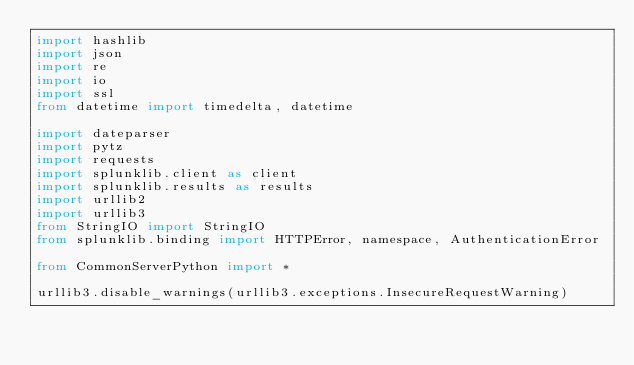<code> <loc_0><loc_0><loc_500><loc_500><_Python_>import hashlib
import json
import re
import io
import ssl
from datetime import timedelta, datetime

import dateparser
import pytz
import requests
import splunklib.client as client
import splunklib.results as results
import urllib2
import urllib3
from StringIO import StringIO
from splunklib.binding import HTTPError, namespace, AuthenticationError

from CommonServerPython import *

urllib3.disable_warnings(urllib3.exceptions.InsecureRequestWarning)
</code> 